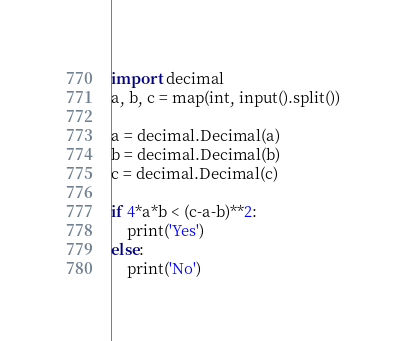<code> <loc_0><loc_0><loc_500><loc_500><_Python_>import decimal
a, b, c = map(int, input().split())

a = decimal.Decimal(a)
b = decimal.Decimal(b)
c = decimal.Decimal(c)

if 4*a*b < (c-a-b)**2:
    print('Yes')
else:
    print('No')
</code> 